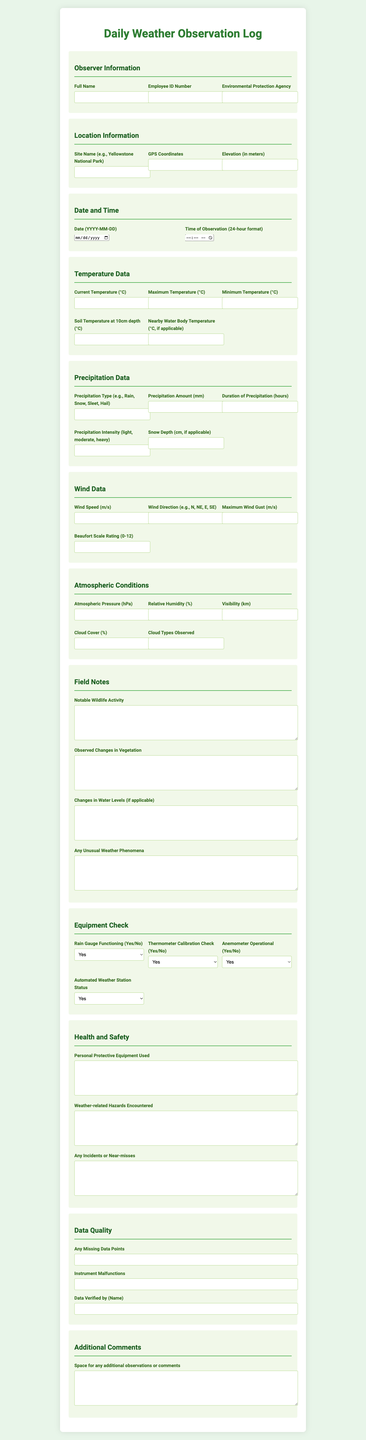what is the title of the document? The title of the document is stated at the top and is "Daily Weather Observation Log."
Answer: Daily Weather Observation Log who is the observer? The observer's name is captured under the observer information section.
Answer: Full Name what is the date of observation? The date is specified in the date and time section.
Answer: Date (YYYY-MM-DD) what is the maximum temperature recorded? The maximum temperature is recorded in the temperature data section.
Answer: Maximum Temperature (°C) how much precipitation was measured? The amount of precipitation is listed under the precipitation data section.
Answer: Precipitation Amount (mm) what is the wind speed? The wind speed is mentioned in the wind data section.
Answer: Wind Speed (m/s) how is the rain gauge functioning? The status of the rain gauge is found in the equipment check section.
Answer: Yes/No what notable wildlife activity was observed? Notable wildlife activity is recorded in the field notes section.
Answer: Notable Wildlife Activity was there any instrument malfunction? The document contains information on instrument malfunctions in the data quality section.
Answer: Yes/No 